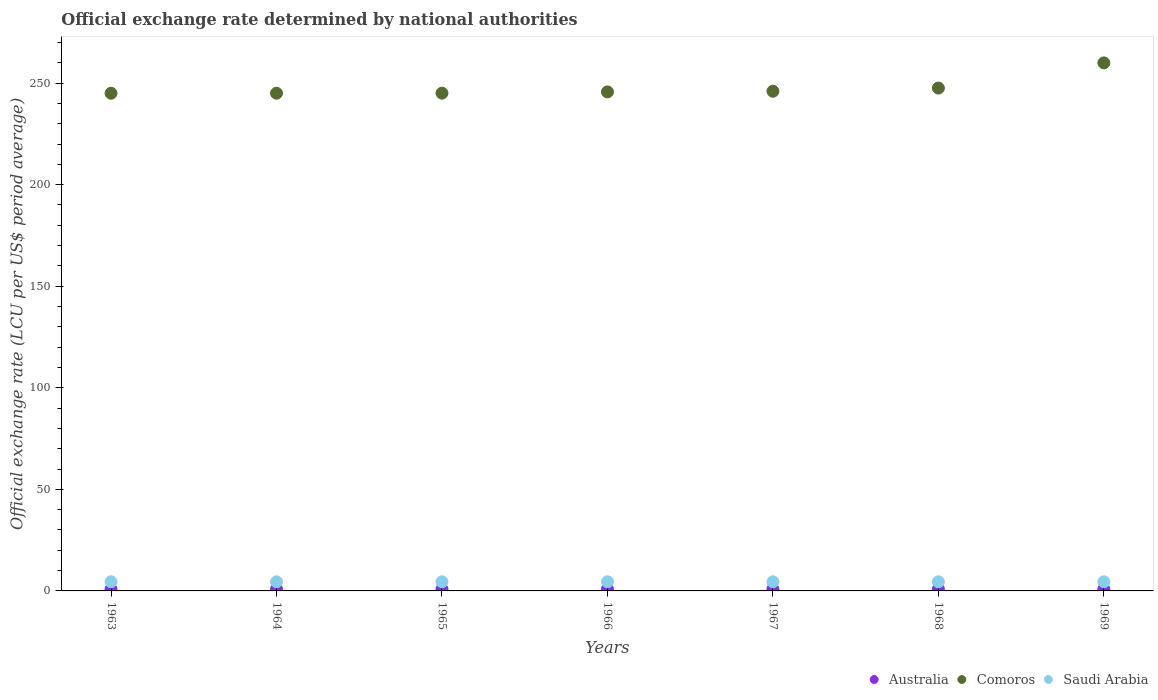How many different coloured dotlines are there?
Ensure brevity in your answer.  3. What is the official exchange rate in Comoros in 1965?
Your answer should be compact. 245.06. Across all years, what is the maximum official exchange rate in Australia?
Ensure brevity in your answer.  0.89. Across all years, what is the minimum official exchange rate in Australia?
Your answer should be very brief. 0.89. What is the total official exchange rate in Australia in the graph?
Provide a short and direct response. 6.25. What is the difference between the official exchange rate in Comoros in 1964 and that in 1966?
Provide a short and direct response. -0.65. What is the difference between the official exchange rate in Comoros in 1967 and the official exchange rate in Australia in 1965?
Your response must be concise. 245.11. What is the average official exchange rate in Comoros per year?
Keep it short and to the point. 247.76. In the year 1963, what is the difference between the official exchange rate in Saudi Arabia and official exchange rate in Australia?
Ensure brevity in your answer.  3.61. What is the ratio of the official exchange rate in Comoros in 1964 to that in 1967?
Ensure brevity in your answer.  1. What is the difference between the highest and the second highest official exchange rate in Australia?
Your response must be concise. 0. What is the difference between the highest and the lowest official exchange rate in Australia?
Make the answer very short. 0. Is the sum of the official exchange rate in Australia in 1963 and 1969 greater than the maximum official exchange rate in Comoros across all years?
Provide a succinct answer. No. Is it the case that in every year, the sum of the official exchange rate in Comoros and official exchange rate in Saudi Arabia  is greater than the official exchange rate in Australia?
Your answer should be very brief. Yes. Is the official exchange rate in Comoros strictly greater than the official exchange rate in Australia over the years?
Ensure brevity in your answer.  Yes. Is the official exchange rate in Australia strictly less than the official exchange rate in Comoros over the years?
Offer a terse response. Yes. What is the difference between two consecutive major ticks on the Y-axis?
Your response must be concise. 50. Are the values on the major ticks of Y-axis written in scientific E-notation?
Offer a very short reply. No. Does the graph contain any zero values?
Make the answer very short. No. Where does the legend appear in the graph?
Give a very brief answer. Bottom right. What is the title of the graph?
Your answer should be compact. Official exchange rate determined by national authorities. What is the label or title of the Y-axis?
Offer a terse response. Official exchange rate (LCU per US$ period average). What is the Official exchange rate (LCU per US$ period average) in Australia in 1963?
Give a very brief answer. 0.89. What is the Official exchange rate (LCU per US$ period average) of Comoros in 1963?
Give a very brief answer. 245.01. What is the Official exchange rate (LCU per US$ period average) of Saudi Arabia in 1963?
Offer a very short reply. 4.5. What is the Official exchange rate (LCU per US$ period average) of Australia in 1964?
Provide a succinct answer. 0.89. What is the Official exchange rate (LCU per US$ period average) of Comoros in 1964?
Give a very brief answer. 245.03. What is the Official exchange rate (LCU per US$ period average) of Saudi Arabia in 1964?
Your answer should be compact. 4.5. What is the Official exchange rate (LCU per US$ period average) of Australia in 1965?
Give a very brief answer. 0.89. What is the Official exchange rate (LCU per US$ period average) of Comoros in 1965?
Your response must be concise. 245.06. What is the Official exchange rate (LCU per US$ period average) in Saudi Arabia in 1965?
Give a very brief answer. 4.5. What is the Official exchange rate (LCU per US$ period average) of Australia in 1966?
Provide a short and direct response. 0.89. What is the Official exchange rate (LCU per US$ period average) in Comoros in 1966?
Keep it short and to the point. 245.68. What is the Official exchange rate (LCU per US$ period average) in Saudi Arabia in 1966?
Ensure brevity in your answer.  4.5. What is the Official exchange rate (LCU per US$ period average) of Australia in 1967?
Make the answer very short. 0.89. What is the Official exchange rate (LCU per US$ period average) of Comoros in 1967?
Make the answer very short. 246. What is the Official exchange rate (LCU per US$ period average) of Saudi Arabia in 1967?
Your answer should be very brief. 4.5. What is the Official exchange rate (LCU per US$ period average) of Australia in 1968?
Give a very brief answer. 0.89. What is the Official exchange rate (LCU per US$ period average) in Comoros in 1968?
Make the answer very short. 247.56. What is the Official exchange rate (LCU per US$ period average) in Saudi Arabia in 1968?
Your answer should be very brief. 4.5. What is the Official exchange rate (LCU per US$ period average) in Australia in 1969?
Your answer should be compact. 0.89. What is the Official exchange rate (LCU per US$ period average) in Comoros in 1969?
Your answer should be compact. 259.96. What is the Official exchange rate (LCU per US$ period average) of Saudi Arabia in 1969?
Give a very brief answer. 4.5. Across all years, what is the maximum Official exchange rate (LCU per US$ period average) in Australia?
Your answer should be compact. 0.89. Across all years, what is the maximum Official exchange rate (LCU per US$ period average) in Comoros?
Offer a terse response. 259.96. Across all years, what is the maximum Official exchange rate (LCU per US$ period average) in Saudi Arabia?
Make the answer very short. 4.5. Across all years, what is the minimum Official exchange rate (LCU per US$ period average) of Australia?
Provide a short and direct response. 0.89. Across all years, what is the minimum Official exchange rate (LCU per US$ period average) in Comoros?
Offer a very short reply. 245.01. Across all years, what is the minimum Official exchange rate (LCU per US$ period average) of Saudi Arabia?
Ensure brevity in your answer.  4.5. What is the total Official exchange rate (LCU per US$ period average) in Australia in the graph?
Your response must be concise. 6.25. What is the total Official exchange rate (LCU per US$ period average) of Comoros in the graph?
Offer a terse response. 1734.29. What is the total Official exchange rate (LCU per US$ period average) in Saudi Arabia in the graph?
Your response must be concise. 31.5. What is the difference between the Official exchange rate (LCU per US$ period average) in Comoros in 1963 and that in 1964?
Your response must be concise. -0.01. What is the difference between the Official exchange rate (LCU per US$ period average) of Australia in 1963 and that in 1965?
Your answer should be compact. 0. What is the difference between the Official exchange rate (LCU per US$ period average) in Comoros in 1963 and that in 1965?
Make the answer very short. -0.04. What is the difference between the Official exchange rate (LCU per US$ period average) of Saudi Arabia in 1963 and that in 1965?
Ensure brevity in your answer.  0. What is the difference between the Official exchange rate (LCU per US$ period average) in Australia in 1963 and that in 1966?
Provide a short and direct response. 0. What is the difference between the Official exchange rate (LCU per US$ period average) of Comoros in 1963 and that in 1966?
Offer a very short reply. -0.66. What is the difference between the Official exchange rate (LCU per US$ period average) of Australia in 1963 and that in 1967?
Provide a short and direct response. 0. What is the difference between the Official exchange rate (LCU per US$ period average) of Comoros in 1963 and that in 1967?
Give a very brief answer. -0.98. What is the difference between the Official exchange rate (LCU per US$ period average) of Comoros in 1963 and that in 1968?
Your answer should be very brief. -2.55. What is the difference between the Official exchange rate (LCU per US$ period average) in Saudi Arabia in 1963 and that in 1968?
Offer a terse response. 0. What is the difference between the Official exchange rate (LCU per US$ period average) in Australia in 1963 and that in 1969?
Your answer should be very brief. 0. What is the difference between the Official exchange rate (LCU per US$ period average) in Comoros in 1963 and that in 1969?
Ensure brevity in your answer.  -14.94. What is the difference between the Official exchange rate (LCU per US$ period average) in Comoros in 1964 and that in 1965?
Give a very brief answer. -0.03. What is the difference between the Official exchange rate (LCU per US$ period average) in Australia in 1964 and that in 1966?
Offer a very short reply. 0. What is the difference between the Official exchange rate (LCU per US$ period average) of Comoros in 1964 and that in 1966?
Provide a succinct answer. -0.65. What is the difference between the Official exchange rate (LCU per US$ period average) of Saudi Arabia in 1964 and that in 1966?
Provide a succinct answer. 0. What is the difference between the Official exchange rate (LCU per US$ period average) in Comoros in 1964 and that in 1967?
Ensure brevity in your answer.  -0.97. What is the difference between the Official exchange rate (LCU per US$ period average) of Saudi Arabia in 1964 and that in 1967?
Offer a terse response. 0. What is the difference between the Official exchange rate (LCU per US$ period average) in Comoros in 1964 and that in 1968?
Provide a short and direct response. -2.54. What is the difference between the Official exchange rate (LCU per US$ period average) of Saudi Arabia in 1964 and that in 1968?
Provide a succinct answer. 0. What is the difference between the Official exchange rate (LCU per US$ period average) of Comoros in 1964 and that in 1969?
Offer a terse response. -14.93. What is the difference between the Official exchange rate (LCU per US$ period average) in Saudi Arabia in 1964 and that in 1969?
Keep it short and to the point. 0. What is the difference between the Official exchange rate (LCU per US$ period average) in Comoros in 1965 and that in 1966?
Offer a very short reply. -0.62. What is the difference between the Official exchange rate (LCU per US$ period average) in Australia in 1965 and that in 1967?
Keep it short and to the point. 0. What is the difference between the Official exchange rate (LCU per US$ period average) in Comoros in 1965 and that in 1967?
Give a very brief answer. -0.94. What is the difference between the Official exchange rate (LCU per US$ period average) of Saudi Arabia in 1965 and that in 1967?
Your response must be concise. 0. What is the difference between the Official exchange rate (LCU per US$ period average) in Comoros in 1965 and that in 1968?
Your answer should be compact. -2.5. What is the difference between the Official exchange rate (LCU per US$ period average) of Comoros in 1965 and that in 1969?
Your response must be concise. -14.9. What is the difference between the Official exchange rate (LCU per US$ period average) of Australia in 1966 and that in 1967?
Your response must be concise. 0. What is the difference between the Official exchange rate (LCU per US$ period average) in Comoros in 1966 and that in 1967?
Your response must be concise. -0.32. What is the difference between the Official exchange rate (LCU per US$ period average) of Saudi Arabia in 1966 and that in 1967?
Provide a succinct answer. 0. What is the difference between the Official exchange rate (LCU per US$ period average) in Comoros in 1966 and that in 1968?
Provide a short and direct response. -1.89. What is the difference between the Official exchange rate (LCU per US$ period average) in Australia in 1966 and that in 1969?
Provide a succinct answer. 0. What is the difference between the Official exchange rate (LCU per US$ period average) of Comoros in 1966 and that in 1969?
Provide a succinct answer. -14.28. What is the difference between the Official exchange rate (LCU per US$ period average) of Comoros in 1967 and that in 1968?
Your answer should be compact. -1.56. What is the difference between the Official exchange rate (LCU per US$ period average) of Comoros in 1967 and that in 1969?
Your answer should be very brief. -13.96. What is the difference between the Official exchange rate (LCU per US$ period average) in Saudi Arabia in 1967 and that in 1969?
Provide a succinct answer. 0. What is the difference between the Official exchange rate (LCU per US$ period average) of Australia in 1968 and that in 1969?
Make the answer very short. 0. What is the difference between the Official exchange rate (LCU per US$ period average) in Comoros in 1968 and that in 1969?
Give a very brief answer. -12.4. What is the difference between the Official exchange rate (LCU per US$ period average) of Australia in 1963 and the Official exchange rate (LCU per US$ period average) of Comoros in 1964?
Ensure brevity in your answer.  -244.13. What is the difference between the Official exchange rate (LCU per US$ period average) in Australia in 1963 and the Official exchange rate (LCU per US$ period average) in Saudi Arabia in 1964?
Ensure brevity in your answer.  -3.61. What is the difference between the Official exchange rate (LCU per US$ period average) in Comoros in 1963 and the Official exchange rate (LCU per US$ period average) in Saudi Arabia in 1964?
Provide a short and direct response. 240.51. What is the difference between the Official exchange rate (LCU per US$ period average) in Australia in 1963 and the Official exchange rate (LCU per US$ period average) in Comoros in 1965?
Your response must be concise. -244.17. What is the difference between the Official exchange rate (LCU per US$ period average) of Australia in 1963 and the Official exchange rate (LCU per US$ period average) of Saudi Arabia in 1965?
Your answer should be compact. -3.61. What is the difference between the Official exchange rate (LCU per US$ period average) of Comoros in 1963 and the Official exchange rate (LCU per US$ period average) of Saudi Arabia in 1965?
Give a very brief answer. 240.51. What is the difference between the Official exchange rate (LCU per US$ period average) of Australia in 1963 and the Official exchange rate (LCU per US$ period average) of Comoros in 1966?
Provide a short and direct response. -244.78. What is the difference between the Official exchange rate (LCU per US$ period average) of Australia in 1963 and the Official exchange rate (LCU per US$ period average) of Saudi Arabia in 1966?
Offer a very short reply. -3.61. What is the difference between the Official exchange rate (LCU per US$ period average) in Comoros in 1963 and the Official exchange rate (LCU per US$ period average) in Saudi Arabia in 1966?
Offer a very short reply. 240.51. What is the difference between the Official exchange rate (LCU per US$ period average) in Australia in 1963 and the Official exchange rate (LCU per US$ period average) in Comoros in 1967?
Provide a short and direct response. -245.11. What is the difference between the Official exchange rate (LCU per US$ period average) of Australia in 1963 and the Official exchange rate (LCU per US$ period average) of Saudi Arabia in 1967?
Your answer should be compact. -3.61. What is the difference between the Official exchange rate (LCU per US$ period average) in Comoros in 1963 and the Official exchange rate (LCU per US$ period average) in Saudi Arabia in 1967?
Keep it short and to the point. 240.51. What is the difference between the Official exchange rate (LCU per US$ period average) of Australia in 1963 and the Official exchange rate (LCU per US$ period average) of Comoros in 1968?
Offer a very short reply. -246.67. What is the difference between the Official exchange rate (LCU per US$ period average) of Australia in 1963 and the Official exchange rate (LCU per US$ period average) of Saudi Arabia in 1968?
Provide a short and direct response. -3.61. What is the difference between the Official exchange rate (LCU per US$ period average) of Comoros in 1963 and the Official exchange rate (LCU per US$ period average) of Saudi Arabia in 1968?
Provide a succinct answer. 240.51. What is the difference between the Official exchange rate (LCU per US$ period average) of Australia in 1963 and the Official exchange rate (LCU per US$ period average) of Comoros in 1969?
Give a very brief answer. -259.07. What is the difference between the Official exchange rate (LCU per US$ period average) of Australia in 1963 and the Official exchange rate (LCU per US$ period average) of Saudi Arabia in 1969?
Provide a succinct answer. -3.61. What is the difference between the Official exchange rate (LCU per US$ period average) in Comoros in 1963 and the Official exchange rate (LCU per US$ period average) in Saudi Arabia in 1969?
Your answer should be compact. 240.51. What is the difference between the Official exchange rate (LCU per US$ period average) of Australia in 1964 and the Official exchange rate (LCU per US$ period average) of Comoros in 1965?
Offer a terse response. -244.17. What is the difference between the Official exchange rate (LCU per US$ period average) in Australia in 1964 and the Official exchange rate (LCU per US$ period average) in Saudi Arabia in 1965?
Offer a very short reply. -3.61. What is the difference between the Official exchange rate (LCU per US$ period average) of Comoros in 1964 and the Official exchange rate (LCU per US$ period average) of Saudi Arabia in 1965?
Make the answer very short. 240.53. What is the difference between the Official exchange rate (LCU per US$ period average) in Australia in 1964 and the Official exchange rate (LCU per US$ period average) in Comoros in 1966?
Your answer should be very brief. -244.78. What is the difference between the Official exchange rate (LCU per US$ period average) in Australia in 1964 and the Official exchange rate (LCU per US$ period average) in Saudi Arabia in 1966?
Offer a very short reply. -3.61. What is the difference between the Official exchange rate (LCU per US$ period average) of Comoros in 1964 and the Official exchange rate (LCU per US$ period average) of Saudi Arabia in 1966?
Offer a terse response. 240.53. What is the difference between the Official exchange rate (LCU per US$ period average) in Australia in 1964 and the Official exchange rate (LCU per US$ period average) in Comoros in 1967?
Your answer should be compact. -245.11. What is the difference between the Official exchange rate (LCU per US$ period average) in Australia in 1964 and the Official exchange rate (LCU per US$ period average) in Saudi Arabia in 1967?
Keep it short and to the point. -3.61. What is the difference between the Official exchange rate (LCU per US$ period average) in Comoros in 1964 and the Official exchange rate (LCU per US$ period average) in Saudi Arabia in 1967?
Your response must be concise. 240.53. What is the difference between the Official exchange rate (LCU per US$ period average) in Australia in 1964 and the Official exchange rate (LCU per US$ period average) in Comoros in 1968?
Give a very brief answer. -246.67. What is the difference between the Official exchange rate (LCU per US$ period average) in Australia in 1964 and the Official exchange rate (LCU per US$ period average) in Saudi Arabia in 1968?
Your answer should be compact. -3.61. What is the difference between the Official exchange rate (LCU per US$ period average) of Comoros in 1964 and the Official exchange rate (LCU per US$ period average) of Saudi Arabia in 1968?
Provide a succinct answer. 240.53. What is the difference between the Official exchange rate (LCU per US$ period average) of Australia in 1964 and the Official exchange rate (LCU per US$ period average) of Comoros in 1969?
Provide a succinct answer. -259.07. What is the difference between the Official exchange rate (LCU per US$ period average) in Australia in 1964 and the Official exchange rate (LCU per US$ period average) in Saudi Arabia in 1969?
Offer a very short reply. -3.61. What is the difference between the Official exchange rate (LCU per US$ period average) in Comoros in 1964 and the Official exchange rate (LCU per US$ period average) in Saudi Arabia in 1969?
Keep it short and to the point. 240.53. What is the difference between the Official exchange rate (LCU per US$ period average) in Australia in 1965 and the Official exchange rate (LCU per US$ period average) in Comoros in 1966?
Provide a succinct answer. -244.78. What is the difference between the Official exchange rate (LCU per US$ period average) in Australia in 1965 and the Official exchange rate (LCU per US$ period average) in Saudi Arabia in 1966?
Keep it short and to the point. -3.61. What is the difference between the Official exchange rate (LCU per US$ period average) in Comoros in 1965 and the Official exchange rate (LCU per US$ period average) in Saudi Arabia in 1966?
Offer a very short reply. 240.56. What is the difference between the Official exchange rate (LCU per US$ period average) of Australia in 1965 and the Official exchange rate (LCU per US$ period average) of Comoros in 1967?
Keep it short and to the point. -245.11. What is the difference between the Official exchange rate (LCU per US$ period average) of Australia in 1965 and the Official exchange rate (LCU per US$ period average) of Saudi Arabia in 1967?
Give a very brief answer. -3.61. What is the difference between the Official exchange rate (LCU per US$ period average) of Comoros in 1965 and the Official exchange rate (LCU per US$ period average) of Saudi Arabia in 1967?
Ensure brevity in your answer.  240.56. What is the difference between the Official exchange rate (LCU per US$ period average) in Australia in 1965 and the Official exchange rate (LCU per US$ period average) in Comoros in 1968?
Ensure brevity in your answer.  -246.67. What is the difference between the Official exchange rate (LCU per US$ period average) of Australia in 1965 and the Official exchange rate (LCU per US$ period average) of Saudi Arabia in 1968?
Your response must be concise. -3.61. What is the difference between the Official exchange rate (LCU per US$ period average) of Comoros in 1965 and the Official exchange rate (LCU per US$ period average) of Saudi Arabia in 1968?
Make the answer very short. 240.56. What is the difference between the Official exchange rate (LCU per US$ period average) of Australia in 1965 and the Official exchange rate (LCU per US$ period average) of Comoros in 1969?
Make the answer very short. -259.07. What is the difference between the Official exchange rate (LCU per US$ period average) of Australia in 1965 and the Official exchange rate (LCU per US$ period average) of Saudi Arabia in 1969?
Offer a terse response. -3.61. What is the difference between the Official exchange rate (LCU per US$ period average) of Comoros in 1965 and the Official exchange rate (LCU per US$ period average) of Saudi Arabia in 1969?
Your response must be concise. 240.56. What is the difference between the Official exchange rate (LCU per US$ period average) in Australia in 1966 and the Official exchange rate (LCU per US$ period average) in Comoros in 1967?
Give a very brief answer. -245.11. What is the difference between the Official exchange rate (LCU per US$ period average) in Australia in 1966 and the Official exchange rate (LCU per US$ period average) in Saudi Arabia in 1967?
Your answer should be very brief. -3.61. What is the difference between the Official exchange rate (LCU per US$ period average) in Comoros in 1966 and the Official exchange rate (LCU per US$ period average) in Saudi Arabia in 1967?
Give a very brief answer. 241.18. What is the difference between the Official exchange rate (LCU per US$ period average) of Australia in 1966 and the Official exchange rate (LCU per US$ period average) of Comoros in 1968?
Offer a very short reply. -246.67. What is the difference between the Official exchange rate (LCU per US$ period average) in Australia in 1966 and the Official exchange rate (LCU per US$ period average) in Saudi Arabia in 1968?
Your answer should be very brief. -3.61. What is the difference between the Official exchange rate (LCU per US$ period average) of Comoros in 1966 and the Official exchange rate (LCU per US$ period average) of Saudi Arabia in 1968?
Make the answer very short. 241.18. What is the difference between the Official exchange rate (LCU per US$ period average) in Australia in 1966 and the Official exchange rate (LCU per US$ period average) in Comoros in 1969?
Keep it short and to the point. -259.07. What is the difference between the Official exchange rate (LCU per US$ period average) in Australia in 1966 and the Official exchange rate (LCU per US$ period average) in Saudi Arabia in 1969?
Make the answer very short. -3.61. What is the difference between the Official exchange rate (LCU per US$ period average) of Comoros in 1966 and the Official exchange rate (LCU per US$ period average) of Saudi Arabia in 1969?
Your answer should be very brief. 241.18. What is the difference between the Official exchange rate (LCU per US$ period average) of Australia in 1967 and the Official exchange rate (LCU per US$ period average) of Comoros in 1968?
Offer a very short reply. -246.67. What is the difference between the Official exchange rate (LCU per US$ period average) in Australia in 1967 and the Official exchange rate (LCU per US$ period average) in Saudi Arabia in 1968?
Provide a succinct answer. -3.61. What is the difference between the Official exchange rate (LCU per US$ period average) of Comoros in 1967 and the Official exchange rate (LCU per US$ period average) of Saudi Arabia in 1968?
Provide a short and direct response. 241.5. What is the difference between the Official exchange rate (LCU per US$ period average) in Australia in 1967 and the Official exchange rate (LCU per US$ period average) in Comoros in 1969?
Make the answer very short. -259.07. What is the difference between the Official exchange rate (LCU per US$ period average) of Australia in 1967 and the Official exchange rate (LCU per US$ period average) of Saudi Arabia in 1969?
Keep it short and to the point. -3.61. What is the difference between the Official exchange rate (LCU per US$ period average) of Comoros in 1967 and the Official exchange rate (LCU per US$ period average) of Saudi Arabia in 1969?
Make the answer very short. 241.5. What is the difference between the Official exchange rate (LCU per US$ period average) of Australia in 1968 and the Official exchange rate (LCU per US$ period average) of Comoros in 1969?
Ensure brevity in your answer.  -259.07. What is the difference between the Official exchange rate (LCU per US$ period average) of Australia in 1968 and the Official exchange rate (LCU per US$ period average) of Saudi Arabia in 1969?
Your response must be concise. -3.61. What is the difference between the Official exchange rate (LCU per US$ period average) in Comoros in 1968 and the Official exchange rate (LCU per US$ period average) in Saudi Arabia in 1969?
Ensure brevity in your answer.  243.06. What is the average Official exchange rate (LCU per US$ period average) of Australia per year?
Provide a short and direct response. 0.89. What is the average Official exchange rate (LCU per US$ period average) of Comoros per year?
Provide a short and direct response. 247.76. What is the average Official exchange rate (LCU per US$ period average) in Saudi Arabia per year?
Offer a terse response. 4.5. In the year 1963, what is the difference between the Official exchange rate (LCU per US$ period average) of Australia and Official exchange rate (LCU per US$ period average) of Comoros?
Keep it short and to the point. -244.12. In the year 1963, what is the difference between the Official exchange rate (LCU per US$ period average) of Australia and Official exchange rate (LCU per US$ period average) of Saudi Arabia?
Give a very brief answer. -3.61. In the year 1963, what is the difference between the Official exchange rate (LCU per US$ period average) in Comoros and Official exchange rate (LCU per US$ period average) in Saudi Arabia?
Provide a short and direct response. 240.51. In the year 1964, what is the difference between the Official exchange rate (LCU per US$ period average) of Australia and Official exchange rate (LCU per US$ period average) of Comoros?
Give a very brief answer. -244.13. In the year 1964, what is the difference between the Official exchange rate (LCU per US$ period average) in Australia and Official exchange rate (LCU per US$ period average) in Saudi Arabia?
Ensure brevity in your answer.  -3.61. In the year 1964, what is the difference between the Official exchange rate (LCU per US$ period average) in Comoros and Official exchange rate (LCU per US$ period average) in Saudi Arabia?
Offer a very short reply. 240.53. In the year 1965, what is the difference between the Official exchange rate (LCU per US$ period average) of Australia and Official exchange rate (LCU per US$ period average) of Comoros?
Make the answer very short. -244.17. In the year 1965, what is the difference between the Official exchange rate (LCU per US$ period average) in Australia and Official exchange rate (LCU per US$ period average) in Saudi Arabia?
Keep it short and to the point. -3.61. In the year 1965, what is the difference between the Official exchange rate (LCU per US$ period average) in Comoros and Official exchange rate (LCU per US$ period average) in Saudi Arabia?
Provide a short and direct response. 240.56. In the year 1966, what is the difference between the Official exchange rate (LCU per US$ period average) of Australia and Official exchange rate (LCU per US$ period average) of Comoros?
Your answer should be compact. -244.78. In the year 1966, what is the difference between the Official exchange rate (LCU per US$ period average) in Australia and Official exchange rate (LCU per US$ period average) in Saudi Arabia?
Make the answer very short. -3.61. In the year 1966, what is the difference between the Official exchange rate (LCU per US$ period average) of Comoros and Official exchange rate (LCU per US$ period average) of Saudi Arabia?
Give a very brief answer. 241.18. In the year 1967, what is the difference between the Official exchange rate (LCU per US$ period average) of Australia and Official exchange rate (LCU per US$ period average) of Comoros?
Offer a very short reply. -245.11. In the year 1967, what is the difference between the Official exchange rate (LCU per US$ period average) in Australia and Official exchange rate (LCU per US$ period average) in Saudi Arabia?
Make the answer very short. -3.61. In the year 1967, what is the difference between the Official exchange rate (LCU per US$ period average) in Comoros and Official exchange rate (LCU per US$ period average) in Saudi Arabia?
Ensure brevity in your answer.  241.5. In the year 1968, what is the difference between the Official exchange rate (LCU per US$ period average) of Australia and Official exchange rate (LCU per US$ period average) of Comoros?
Offer a terse response. -246.67. In the year 1968, what is the difference between the Official exchange rate (LCU per US$ period average) in Australia and Official exchange rate (LCU per US$ period average) in Saudi Arabia?
Keep it short and to the point. -3.61. In the year 1968, what is the difference between the Official exchange rate (LCU per US$ period average) of Comoros and Official exchange rate (LCU per US$ period average) of Saudi Arabia?
Your response must be concise. 243.06. In the year 1969, what is the difference between the Official exchange rate (LCU per US$ period average) of Australia and Official exchange rate (LCU per US$ period average) of Comoros?
Provide a succinct answer. -259.07. In the year 1969, what is the difference between the Official exchange rate (LCU per US$ period average) in Australia and Official exchange rate (LCU per US$ period average) in Saudi Arabia?
Offer a terse response. -3.61. In the year 1969, what is the difference between the Official exchange rate (LCU per US$ period average) in Comoros and Official exchange rate (LCU per US$ period average) in Saudi Arabia?
Your response must be concise. 255.46. What is the ratio of the Official exchange rate (LCU per US$ period average) in Australia in 1963 to that in 1964?
Offer a very short reply. 1. What is the ratio of the Official exchange rate (LCU per US$ period average) of Comoros in 1963 to that in 1964?
Provide a succinct answer. 1. What is the ratio of the Official exchange rate (LCU per US$ period average) in Comoros in 1963 to that in 1965?
Your response must be concise. 1. What is the ratio of the Official exchange rate (LCU per US$ period average) of Australia in 1963 to that in 1966?
Keep it short and to the point. 1. What is the ratio of the Official exchange rate (LCU per US$ period average) in Comoros in 1963 to that in 1966?
Your answer should be compact. 1. What is the ratio of the Official exchange rate (LCU per US$ period average) of Saudi Arabia in 1963 to that in 1966?
Ensure brevity in your answer.  1. What is the ratio of the Official exchange rate (LCU per US$ period average) in Comoros in 1963 to that in 1967?
Provide a succinct answer. 1. What is the ratio of the Official exchange rate (LCU per US$ period average) in Saudi Arabia in 1963 to that in 1967?
Make the answer very short. 1. What is the ratio of the Official exchange rate (LCU per US$ period average) in Australia in 1963 to that in 1968?
Your response must be concise. 1. What is the ratio of the Official exchange rate (LCU per US$ period average) of Saudi Arabia in 1963 to that in 1968?
Ensure brevity in your answer.  1. What is the ratio of the Official exchange rate (LCU per US$ period average) in Australia in 1963 to that in 1969?
Your answer should be compact. 1. What is the ratio of the Official exchange rate (LCU per US$ period average) of Comoros in 1963 to that in 1969?
Your answer should be compact. 0.94. What is the ratio of the Official exchange rate (LCU per US$ period average) in Saudi Arabia in 1964 to that in 1965?
Provide a succinct answer. 1. What is the ratio of the Official exchange rate (LCU per US$ period average) of Australia in 1964 to that in 1966?
Provide a short and direct response. 1. What is the ratio of the Official exchange rate (LCU per US$ period average) of Comoros in 1964 to that in 1966?
Provide a succinct answer. 1. What is the ratio of the Official exchange rate (LCU per US$ period average) of Saudi Arabia in 1964 to that in 1966?
Make the answer very short. 1. What is the ratio of the Official exchange rate (LCU per US$ period average) in Australia in 1964 to that in 1967?
Your response must be concise. 1. What is the ratio of the Official exchange rate (LCU per US$ period average) in Saudi Arabia in 1964 to that in 1967?
Offer a terse response. 1. What is the ratio of the Official exchange rate (LCU per US$ period average) in Saudi Arabia in 1964 to that in 1968?
Give a very brief answer. 1. What is the ratio of the Official exchange rate (LCU per US$ period average) of Comoros in 1964 to that in 1969?
Give a very brief answer. 0.94. What is the ratio of the Official exchange rate (LCU per US$ period average) of Comoros in 1965 to that in 1967?
Your response must be concise. 1. What is the ratio of the Official exchange rate (LCU per US$ period average) of Saudi Arabia in 1965 to that in 1967?
Your response must be concise. 1. What is the ratio of the Official exchange rate (LCU per US$ period average) in Australia in 1965 to that in 1968?
Your answer should be very brief. 1. What is the ratio of the Official exchange rate (LCU per US$ period average) of Comoros in 1965 to that in 1968?
Provide a short and direct response. 0.99. What is the ratio of the Official exchange rate (LCU per US$ period average) of Comoros in 1965 to that in 1969?
Provide a short and direct response. 0.94. What is the ratio of the Official exchange rate (LCU per US$ period average) of Saudi Arabia in 1966 to that in 1968?
Your response must be concise. 1. What is the ratio of the Official exchange rate (LCU per US$ period average) in Australia in 1966 to that in 1969?
Offer a terse response. 1. What is the ratio of the Official exchange rate (LCU per US$ period average) in Comoros in 1966 to that in 1969?
Give a very brief answer. 0.95. What is the ratio of the Official exchange rate (LCU per US$ period average) of Comoros in 1967 to that in 1968?
Your response must be concise. 0.99. What is the ratio of the Official exchange rate (LCU per US$ period average) of Australia in 1967 to that in 1969?
Make the answer very short. 1. What is the ratio of the Official exchange rate (LCU per US$ period average) in Comoros in 1967 to that in 1969?
Offer a terse response. 0.95. What is the ratio of the Official exchange rate (LCU per US$ period average) in Saudi Arabia in 1967 to that in 1969?
Provide a short and direct response. 1. What is the ratio of the Official exchange rate (LCU per US$ period average) of Comoros in 1968 to that in 1969?
Your answer should be very brief. 0.95. What is the difference between the highest and the second highest Official exchange rate (LCU per US$ period average) of Australia?
Your answer should be very brief. 0. What is the difference between the highest and the second highest Official exchange rate (LCU per US$ period average) of Comoros?
Ensure brevity in your answer.  12.4. What is the difference between the highest and the lowest Official exchange rate (LCU per US$ period average) in Comoros?
Offer a very short reply. 14.94. 